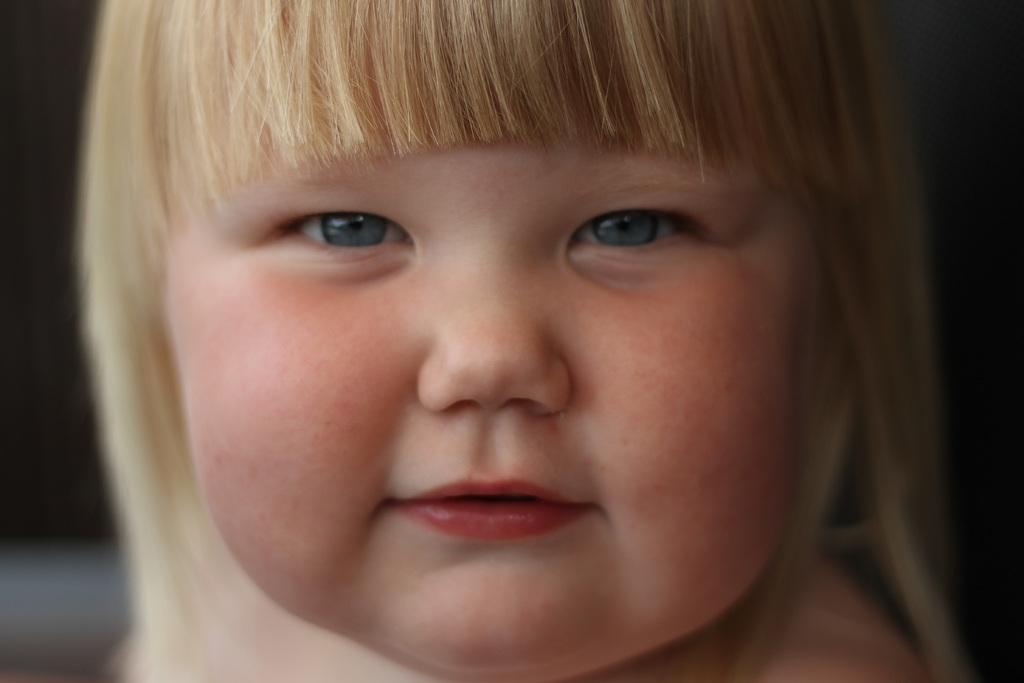What is the main subject of the image? The main subject of the image is the face of a kid. What type of tooth can be seen in the image? There is no tooth present in the image; it features the face of a kid. What is the temperature outside the window in the image? There is no window or indication of temperature in the image, as it only shows the face of a kid. 